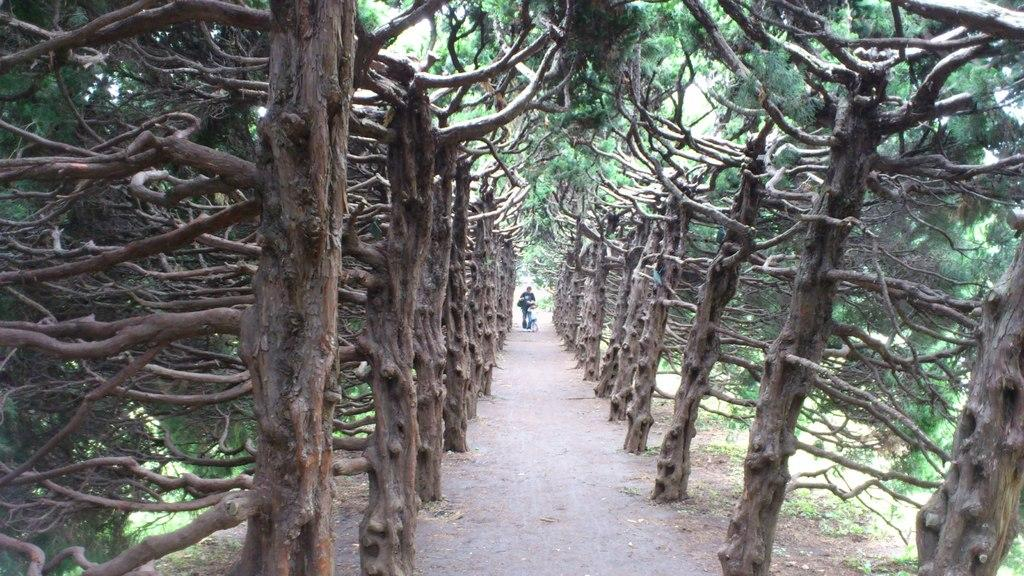What type of vegetation can be seen in the image? There are trees in the image. What part of the trees is visible in the image? There are branches in the image. Can you describe the people in the background of the image? There are two people in the background of the image. What example of a thing can be seen in the image? The trees and branches in the image are examples of things, but the question is too vague to answer definitively. 